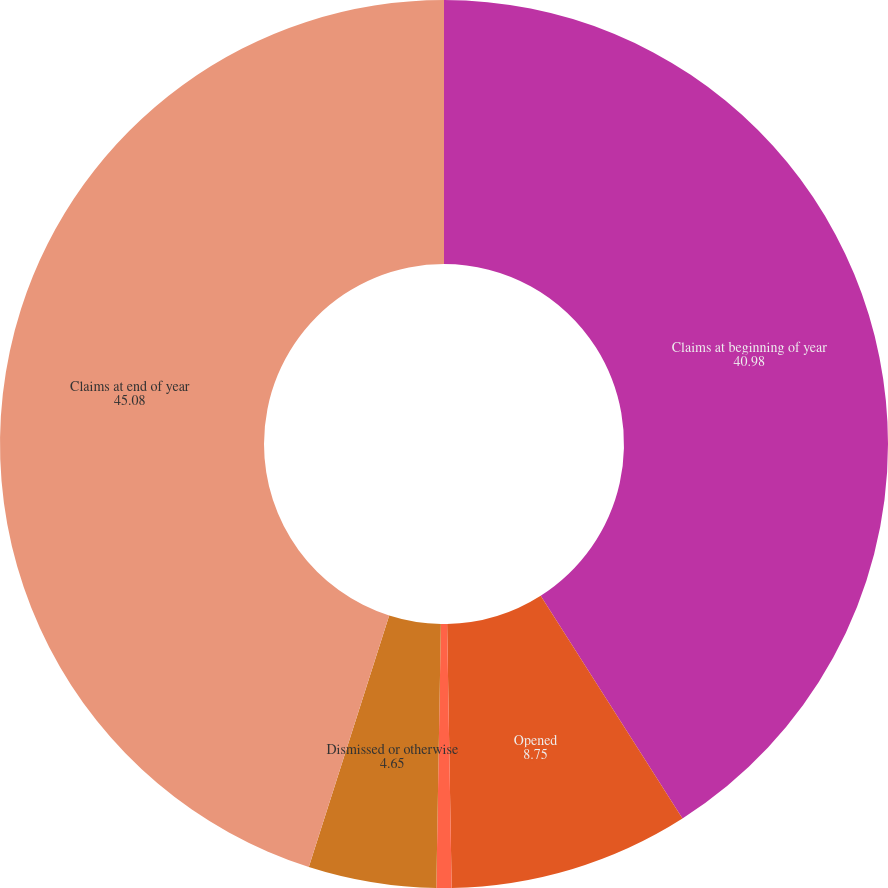Convert chart to OTSL. <chart><loc_0><loc_0><loc_500><loc_500><pie_chart><fcel>Claims at beginning of year<fcel>Opened<fcel>Settled<fcel>Dismissed or otherwise<fcel>Claims at end of year<nl><fcel>40.98%<fcel>8.75%<fcel>0.55%<fcel>4.65%<fcel>45.08%<nl></chart> 